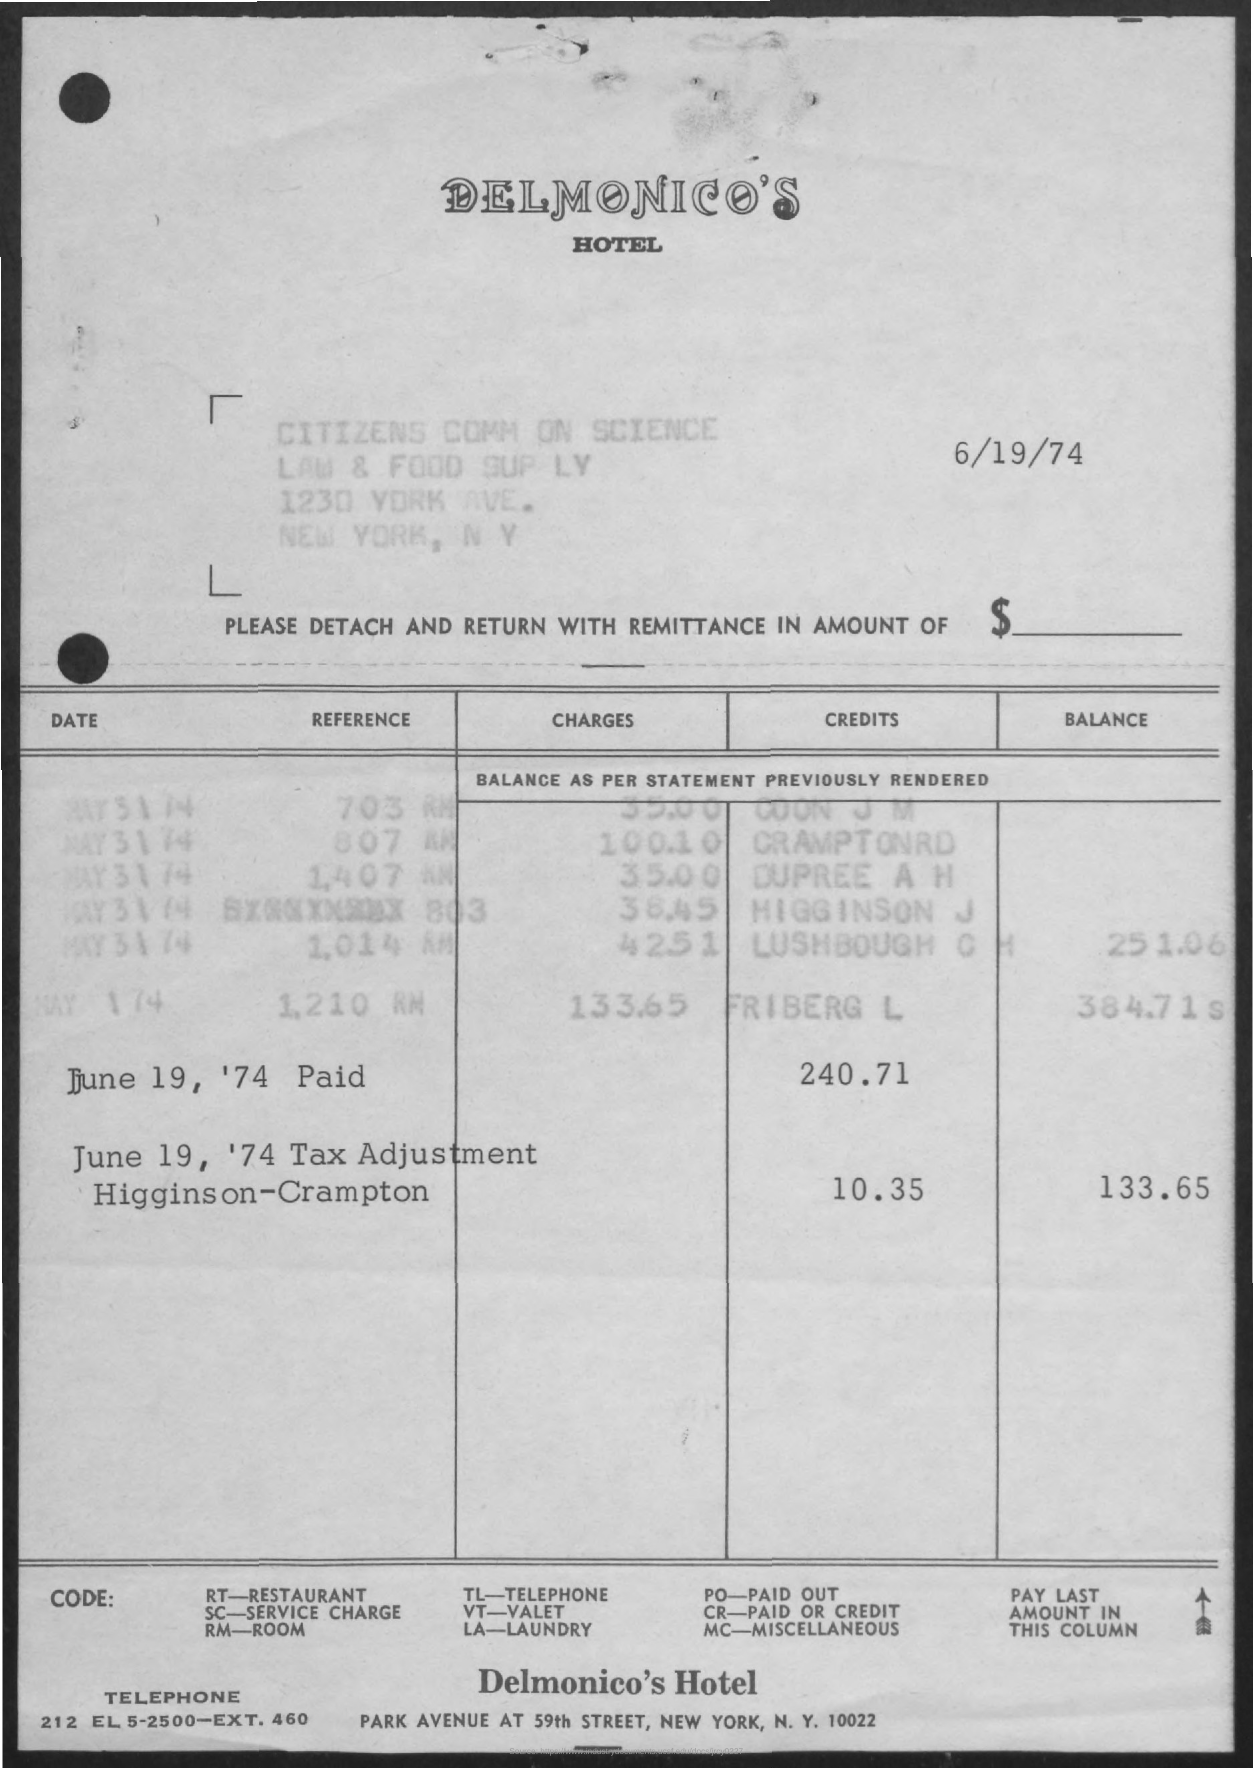Highlight a few significant elements in this photo. The date mentioned at the top right of the document is 6/19/74. The code for Paid or Credit is 'cr..'. The first title in the document is 'Delmonico's.' 